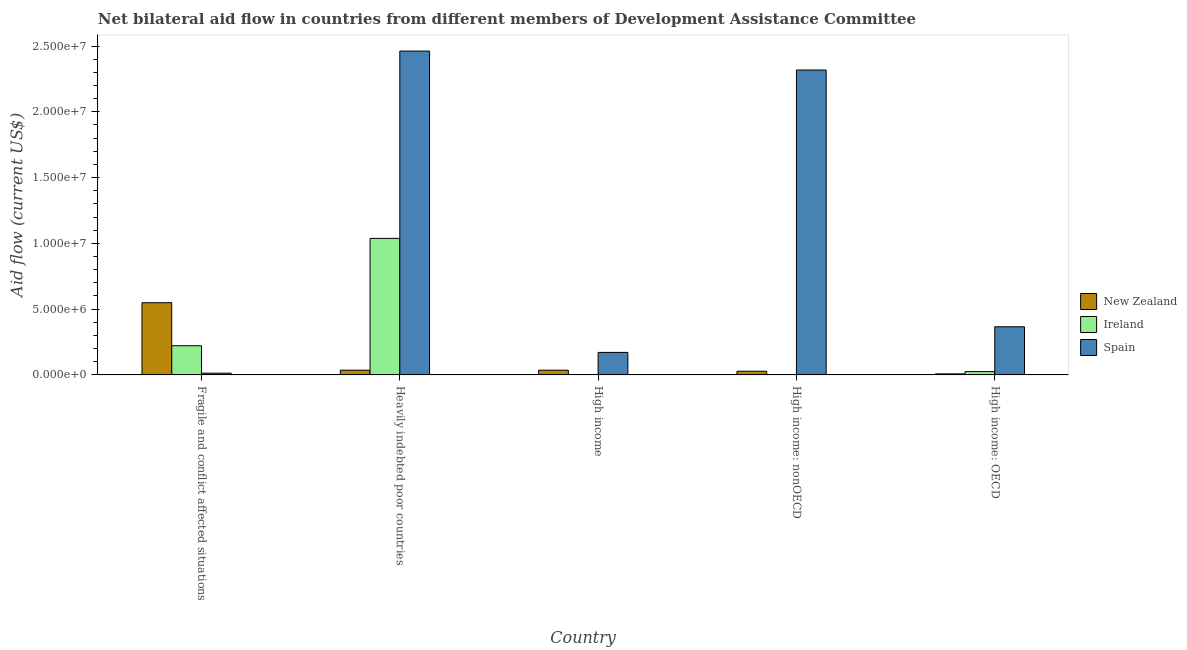What is the label of the 5th group of bars from the left?
Your answer should be very brief. High income: OECD. In how many cases, is the number of bars for a given country not equal to the number of legend labels?
Your response must be concise. 0. What is the amount of aid provided by spain in Heavily indebted poor countries?
Your response must be concise. 2.46e+07. Across all countries, what is the maximum amount of aid provided by new zealand?
Make the answer very short. 5.49e+06. Across all countries, what is the minimum amount of aid provided by spain?
Offer a very short reply. 1.30e+05. In which country was the amount of aid provided by new zealand maximum?
Offer a very short reply. Fragile and conflict affected situations. In which country was the amount of aid provided by spain minimum?
Offer a terse response. Fragile and conflict affected situations. What is the total amount of aid provided by new zealand in the graph?
Provide a short and direct response. 6.57e+06. What is the difference between the amount of aid provided by ireland in Heavily indebted poor countries and that in High income?
Your answer should be compact. 1.04e+07. What is the difference between the amount of aid provided by ireland in High income: OECD and the amount of aid provided by new zealand in High income?
Ensure brevity in your answer.  -1.10e+05. What is the average amount of aid provided by new zealand per country?
Offer a terse response. 1.31e+06. What is the difference between the amount of aid provided by new zealand and amount of aid provided by ireland in High income: nonOECD?
Offer a very short reply. 2.60e+05. What is the ratio of the amount of aid provided by new zealand in Fragile and conflict affected situations to that in Heavily indebted poor countries?
Your answer should be very brief. 15.25. What is the difference between the highest and the second highest amount of aid provided by new zealand?
Your response must be concise. 5.13e+06. What is the difference between the highest and the lowest amount of aid provided by spain?
Your answer should be very brief. 2.45e+07. In how many countries, is the amount of aid provided by spain greater than the average amount of aid provided by spain taken over all countries?
Offer a very short reply. 2. What does the 1st bar from the left in High income: nonOECD represents?
Keep it short and to the point. New Zealand. What does the 2nd bar from the right in Fragile and conflict affected situations represents?
Give a very brief answer. Ireland. How many bars are there?
Make the answer very short. 15. Does the graph contain grids?
Your response must be concise. No. Where does the legend appear in the graph?
Provide a succinct answer. Center right. How many legend labels are there?
Offer a terse response. 3. What is the title of the graph?
Keep it short and to the point. Net bilateral aid flow in countries from different members of Development Assistance Committee. What is the label or title of the X-axis?
Provide a succinct answer. Country. What is the label or title of the Y-axis?
Your answer should be very brief. Aid flow (current US$). What is the Aid flow (current US$) of New Zealand in Fragile and conflict affected situations?
Your answer should be compact. 5.49e+06. What is the Aid flow (current US$) in Ireland in Fragile and conflict affected situations?
Ensure brevity in your answer.  2.22e+06. What is the Aid flow (current US$) in Ireland in Heavily indebted poor countries?
Keep it short and to the point. 1.04e+07. What is the Aid flow (current US$) of Spain in Heavily indebted poor countries?
Provide a short and direct response. 2.46e+07. What is the Aid flow (current US$) of Spain in High income?
Offer a very short reply. 1.71e+06. What is the Aid flow (current US$) in New Zealand in High income: nonOECD?
Offer a terse response. 2.80e+05. What is the Aid flow (current US$) in Ireland in High income: nonOECD?
Offer a terse response. 2.00e+04. What is the Aid flow (current US$) of Spain in High income: nonOECD?
Your response must be concise. 2.32e+07. What is the Aid flow (current US$) of Ireland in High income: OECD?
Provide a succinct answer. 2.50e+05. What is the Aid flow (current US$) in Spain in High income: OECD?
Ensure brevity in your answer.  3.66e+06. Across all countries, what is the maximum Aid flow (current US$) of New Zealand?
Provide a short and direct response. 5.49e+06. Across all countries, what is the maximum Aid flow (current US$) in Ireland?
Your response must be concise. 1.04e+07. Across all countries, what is the maximum Aid flow (current US$) in Spain?
Give a very brief answer. 2.46e+07. What is the total Aid flow (current US$) of New Zealand in the graph?
Ensure brevity in your answer.  6.57e+06. What is the total Aid flow (current US$) of Ireland in the graph?
Offer a very short reply. 1.29e+07. What is the total Aid flow (current US$) in Spain in the graph?
Give a very brief answer. 5.33e+07. What is the difference between the Aid flow (current US$) in New Zealand in Fragile and conflict affected situations and that in Heavily indebted poor countries?
Offer a terse response. 5.13e+06. What is the difference between the Aid flow (current US$) in Ireland in Fragile and conflict affected situations and that in Heavily indebted poor countries?
Your answer should be very brief. -8.16e+06. What is the difference between the Aid flow (current US$) of Spain in Fragile and conflict affected situations and that in Heavily indebted poor countries?
Offer a terse response. -2.45e+07. What is the difference between the Aid flow (current US$) in New Zealand in Fragile and conflict affected situations and that in High income?
Provide a succinct answer. 5.13e+06. What is the difference between the Aid flow (current US$) in Ireland in Fragile and conflict affected situations and that in High income?
Make the answer very short. 2.20e+06. What is the difference between the Aid flow (current US$) in Spain in Fragile and conflict affected situations and that in High income?
Your answer should be compact. -1.58e+06. What is the difference between the Aid flow (current US$) of New Zealand in Fragile and conflict affected situations and that in High income: nonOECD?
Give a very brief answer. 5.21e+06. What is the difference between the Aid flow (current US$) in Ireland in Fragile and conflict affected situations and that in High income: nonOECD?
Offer a terse response. 2.20e+06. What is the difference between the Aid flow (current US$) in Spain in Fragile and conflict affected situations and that in High income: nonOECD?
Your response must be concise. -2.30e+07. What is the difference between the Aid flow (current US$) of New Zealand in Fragile and conflict affected situations and that in High income: OECD?
Your answer should be compact. 5.41e+06. What is the difference between the Aid flow (current US$) of Ireland in Fragile and conflict affected situations and that in High income: OECD?
Give a very brief answer. 1.97e+06. What is the difference between the Aid flow (current US$) in Spain in Fragile and conflict affected situations and that in High income: OECD?
Give a very brief answer. -3.53e+06. What is the difference between the Aid flow (current US$) of New Zealand in Heavily indebted poor countries and that in High income?
Your answer should be compact. 0. What is the difference between the Aid flow (current US$) of Ireland in Heavily indebted poor countries and that in High income?
Your answer should be compact. 1.04e+07. What is the difference between the Aid flow (current US$) of Spain in Heavily indebted poor countries and that in High income?
Your answer should be compact. 2.29e+07. What is the difference between the Aid flow (current US$) in Ireland in Heavily indebted poor countries and that in High income: nonOECD?
Provide a succinct answer. 1.04e+07. What is the difference between the Aid flow (current US$) in Spain in Heavily indebted poor countries and that in High income: nonOECD?
Give a very brief answer. 1.44e+06. What is the difference between the Aid flow (current US$) in Ireland in Heavily indebted poor countries and that in High income: OECD?
Provide a succinct answer. 1.01e+07. What is the difference between the Aid flow (current US$) in Spain in Heavily indebted poor countries and that in High income: OECD?
Ensure brevity in your answer.  2.10e+07. What is the difference between the Aid flow (current US$) in Spain in High income and that in High income: nonOECD?
Your answer should be compact. -2.15e+07. What is the difference between the Aid flow (current US$) of New Zealand in High income and that in High income: OECD?
Make the answer very short. 2.80e+05. What is the difference between the Aid flow (current US$) in Spain in High income and that in High income: OECD?
Provide a succinct answer. -1.95e+06. What is the difference between the Aid flow (current US$) of New Zealand in High income: nonOECD and that in High income: OECD?
Offer a very short reply. 2.00e+05. What is the difference between the Aid flow (current US$) in Ireland in High income: nonOECD and that in High income: OECD?
Offer a terse response. -2.30e+05. What is the difference between the Aid flow (current US$) in Spain in High income: nonOECD and that in High income: OECD?
Keep it short and to the point. 1.95e+07. What is the difference between the Aid flow (current US$) of New Zealand in Fragile and conflict affected situations and the Aid flow (current US$) of Ireland in Heavily indebted poor countries?
Give a very brief answer. -4.89e+06. What is the difference between the Aid flow (current US$) in New Zealand in Fragile and conflict affected situations and the Aid flow (current US$) in Spain in Heavily indebted poor countries?
Provide a succinct answer. -1.91e+07. What is the difference between the Aid flow (current US$) in Ireland in Fragile and conflict affected situations and the Aid flow (current US$) in Spain in Heavily indebted poor countries?
Make the answer very short. -2.24e+07. What is the difference between the Aid flow (current US$) of New Zealand in Fragile and conflict affected situations and the Aid flow (current US$) of Ireland in High income?
Offer a very short reply. 5.47e+06. What is the difference between the Aid flow (current US$) of New Zealand in Fragile and conflict affected situations and the Aid flow (current US$) of Spain in High income?
Give a very brief answer. 3.78e+06. What is the difference between the Aid flow (current US$) in Ireland in Fragile and conflict affected situations and the Aid flow (current US$) in Spain in High income?
Provide a short and direct response. 5.10e+05. What is the difference between the Aid flow (current US$) of New Zealand in Fragile and conflict affected situations and the Aid flow (current US$) of Ireland in High income: nonOECD?
Provide a short and direct response. 5.47e+06. What is the difference between the Aid flow (current US$) of New Zealand in Fragile and conflict affected situations and the Aid flow (current US$) of Spain in High income: nonOECD?
Give a very brief answer. -1.77e+07. What is the difference between the Aid flow (current US$) of Ireland in Fragile and conflict affected situations and the Aid flow (current US$) of Spain in High income: nonOECD?
Provide a short and direct response. -2.10e+07. What is the difference between the Aid flow (current US$) in New Zealand in Fragile and conflict affected situations and the Aid flow (current US$) in Ireland in High income: OECD?
Your answer should be compact. 5.24e+06. What is the difference between the Aid flow (current US$) in New Zealand in Fragile and conflict affected situations and the Aid flow (current US$) in Spain in High income: OECD?
Make the answer very short. 1.83e+06. What is the difference between the Aid flow (current US$) in Ireland in Fragile and conflict affected situations and the Aid flow (current US$) in Spain in High income: OECD?
Provide a succinct answer. -1.44e+06. What is the difference between the Aid flow (current US$) in New Zealand in Heavily indebted poor countries and the Aid flow (current US$) in Ireland in High income?
Give a very brief answer. 3.40e+05. What is the difference between the Aid flow (current US$) of New Zealand in Heavily indebted poor countries and the Aid flow (current US$) of Spain in High income?
Keep it short and to the point. -1.35e+06. What is the difference between the Aid flow (current US$) of Ireland in Heavily indebted poor countries and the Aid flow (current US$) of Spain in High income?
Ensure brevity in your answer.  8.67e+06. What is the difference between the Aid flow (current US$) of New Zealand in Heavily indebted poor countries and the Aid flow (current US$) of Ireland in High income: nonOECD?
Offer a very short reply. 3.40e+05. What is the difference between the Aid flow (current US$) in New Zealand in Heavily indebted poor countries and the Aid flow (current US$) in Spain in High income: nonOECD?
Your answer should be very brief. -2.28e+07. What is the difference between the Aid flow (current US$) in Ireland in Heavily indebted poor countries and the Aid flow (current US$) in Spain in High income: nonOECD?
Keep it short and to the point. -1.28e+07. What is the difference between the Aid flow (current US$) in New Zealand in Heavily indebted poor countries and the Aid flow (current US$) in Spain in High income: OECD?
Offer a very short reply. -3.30e+06. What is the difference between the Aid flow (current US$) in Ireland in Heavily indebted poor countries and the Aid flow (current US$) in Spain in High income: OECD?
Make the answer very short. 6.72e+06. What is the difference between the Aid flow (current US$) of New Zealand in High income and the Aid flow (current US$) of Ireland in High income: nonOECD?
Provide a short and direct response. 3.40e+05. What is the difference between the Aid flow (current US$) of New Zealand in High income and the Aid flow (current US$) of Spain in High income: nonOECD?
Ensure brevity in your answer.  -2.28e+07. What is the difference between the Aid flow (current US$) of Ireland in High income and the Aid flow (current US$) of Spain in High income: nonOECD?
Offer a terse response. -2.32e+07. What is the difference between the Aid flow (current US$) in New Zealand in High income and the Aid flow (current US$) in Ireland in High income: OECD?
Offer a terse response. 1.10e+05. What is the difference between the Aid flow (current US$) of New Zealand in High income and the Aid flow (current US$) of Spain in High income: OECD?
Offer a very short reply. -3.30e+06. What is the difference between the Aid flow (current US$) of Ireland in High income and the Aid flow (current US$) of Spain in High income: OECD?
Your answer should be very brief. -3.64e+06. What is the difference between the Aid flow (current US$) of New Zealand in High income: nonOECD and the Aid flow (current US$) of Spain in High income: OECD?
Provide a short and direct response. -3.38e+06. What is the difference between the Aid flow (current US$) of Ireland in High income: nonOECD and the Aid flow (current US$) of Spain in High income: OECD?
Make the answer very short. -3.64e+06. What is the average Aid flow (current US$) of New Zealand per country?
Your answer should be compact. 1.31e+06. What is the average Aid flow (current US$) of Ireland per country?
Ensure brevity in your answer.  2.58e+06. What is the average Aid flow (current US$) in Spain per country?
Offer a very short reply. 1.07e+07. What is the difference between the Aid flow (current US$) of New Zealand and Aid flow (current US$) of Ireland in Fragile and conflict affected situations?
Your answer should be compact. 3.27e+06. What is the difference between the Aid flow (current US$) in New Zealand and Aid flow (current US$) in Spain in Fragile and conflict affected situations?
Offer a terse response. 5.36e+06. What is the difference between the Aid flow (current US$) of Ireland and Aid flow (current US$) of Spain in Fragile and conflict affected situations?
Your answer should be compact. 2.09e+06. What is the difference between the Aid flow (current US$) in New Zealand and Aid flow (current US$) in Ireland in Heavily indebted poor countries?
Keep it short and to the point. -1.00e+07. What is the difference between the Aid flow (current US$) in New Zealand and Aid flow (current US$) in Spain in Heavily indebted poor countries?
Your answer should be very brief. -2.43e+07. What is the difference between the Aid flow (current US$) of Ireland and Aid flow (current US$) of Spain in Heavily indebted poor countries?
Give a very brief answer. -1.42e+07. What is the difference between the Aid flow (current US$) of New Zealand and Aid flow (current US$) of Ireland in High income?
Provide a succinct answer. 3.40e+05. What is the difference between the Aid flow (current US$) of New Zealand and Aid flow (current US$) of Spain in High income?
Give a very brief answer. -1.35e+06. What is the difference between the Aid flow (current US$) of Ireland and Aid flow (current US$) of Spain in High income?
Your answer should be compact. -1.69e+06. What is the difference between the Aid flow (current US$) in New Zealand and Aid flow (current US$) in Spain in High income: nonOECD?
Make the answer very short. -2.29e+07. What is the difference between the Aid flow (current US$) of Ireland and Aid flow (current US$) of Spain in High income: nonOECD?
Provide a succinct answer. -2.32e+07. What is the difference between the Aid flow (current US$) of New Zealand and Aid flow (current US$) of Spain in High income: OECD?
Provide a succinct answer. -3.58e+06. What is the difference between the Aid flow (current US$) of Ireland and Aid flow (current US$) of Spain in High income: OECD?
Provide a succinct answer. -3.41e+06. What is the ratio of the Aid flow (current US$) in New Zealand in Fragile and conflict affected situations to that in Heavily indebted poor countries?
Your response must be concise. 15.25. What is the ratio of the Aid flow (current US$) of Ireland in Fragile and conflict affected situations to that in Heavily indebted poor countries?
Keep it short and to the point. 0.21. What is the ratio of the Aid flow (current US$) of Spain in Fragile and conflict affected situations to that in Heavily indebted poor countries?
Provide a succinct answer. 0.01. What is the ratio of the Aid flow (current US$) in New Zealand in Fragile and conflict affected situations to that in High income?
Keep it short and to the point. 15.25. What is the ratio of the Aid flow (current US$) in Ireland in Fragile and conflict affected situations to that in High income?
Keep it short and to the point. 111. What is the ratio of the Aid flow (current US$) of Spain in Fragile and conflict affected situations to that in High income?
Your answer should be very brief. 0.08. What is the ratio of the Aid flow (current US$) in New Zealand in Fragile and conflict affected situations to that in High income: nonOECD?
Make the answer very short. 19.61. What is the ratio of the Aid flow (current US$) in Ireland in Fragile and conflict affected situations to that in High income: nonOECD?
Offer a very short reply. 111. What is the ratio of the Aid flow (current US$) of Spain in Fragile and conflict affected situations to that in High income: nonOECD?
Offer a terse response. 0.01. What is the ratio of the Aid flow (current US$) in New Zealand in Fragile and conflict affected situations to that in High income: OECD?
Offer a terse response. 68.62. What is the ratio of the Aid flow (current US$) in Ireland in Fragile and conflict affected situations to that in High income: OECD?
Ensure brevity in your answer.  8.88. What is the ratio of the Aid flow (current US$) of Spain in Fragile and conflict affected situations to that in High income: OECD?
Make the answer very short. 0.04. What is the ratio of the Aid flow (current US$) in New Zealand in Heavily indebted poor countries to that in High income?
Your response must be concise. 1. What is the ratio of the Aid flow (current US$) of Ireland in Heavily indebted poor countries to that in High income?
Ensure brevity in your answer.  519. What is the ratio of the Aid flow (current US$) in Spain in Heavily indebted poor countries to that in High income?
Give a very brief answer. 14.4. What is the ratio of the Aid flow (current US$) of New Zealand in Heavily indebted poor countries to that in High income: nonOECD?
Your answer should be very brief. 1.29. What is the ratio of the Aid flow (current US$) in Ireland in Heavily indebted poor countries to that in High income: nonOECD?
Make the answer very short. 519. What is the ratio of the Aid flow (current US$) in Spain in Heavily indebted poor countries to that in High income: nonOECD?
Offer a very short reply. 1.06. What is the ratio of the Aid flow (current US$) of Ireland in Heavily indebted poor countries to that in High income: OECD?
Keep it short and to the point. 41.52. What is the ratio of the Aid flow (current US$) in Spain in Heavily indebted poor countries to that in High income: OECD?
Make the answer very short. 6.73. What is the ratio of the Aid flow (current US$) of New Zealand in High income to that in High income: nonOECD?
Keep it short and to the point. 1.29. What is the ratio of the Aid flow (current US$) of Spain in High income to that in High income: nonOECD?
Your answer should be very brief. 0.07. What is the ratio of the Aid flow (current US$) of Ireland in High income to that in High income: OECD?
Your response must be concise. 0.08. What is the ratio of the Aid flow (current US$) of Spain in High income to that in High income: OECD?
Keep it short and to the point. 0.47. What is the ratio of the Aid flow (current US$) of Spain in High income: nonOECD to that in High income: OECD?
Give a very brief answer. 6.33. What is the difference between the highest and the second highest Aid flow (current US$) of New Zealand?
Ensure brevity in your answer.  5.13e+06. What is the difference between the highest and the second highest Aid flow (current US$) of Ireland?
Ensure brevity in your answer.  8.16e+06. What is the difference between the highest and the second highest Aid flow (current US$) of Spain?
Your answer should be compact. 1.44e+06. What is the difference between the highest and the lowest Aid flow (current US$) of New Zealand?
Your response must be concise. 5.41e+06. What is the difference between the highest and the lowest Aid flow (current US$) of Ireland?
Give a very brief answer. 1.04e+07. What is the difference between the highest and the lowest Aid flow (current US$) in Spain?
Your answer should be compact. 2.45e+07. 